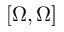Convert formula to latex. <formula><loc_0><loc_0><loc_500><loc_500>[ \Omega , \Omega ]</formula> 